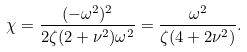Convert formula to latex. <formula><loc_0><loc_0><loc_500><loc_500>\chi = \frac { ( - \omega ^ { 2 } ) ^ { 2 } } { 2 \zeta ( 2 + \nu ^ { 2 } ) \omega ^ { 2 } } = \frac { \omega ^ { 2 } } { \zeta ( 4 + 2 \nu ^ { 2 } ) } .</formula> 